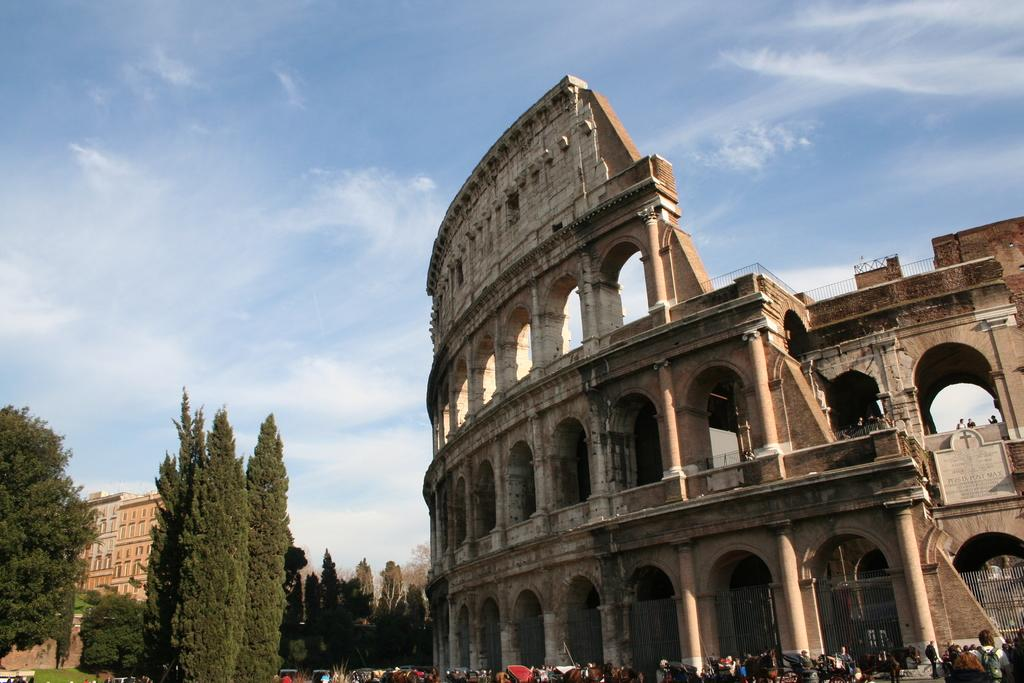What type of structures can be seen in the image? There are buildings in the image. What type of natural elements can be seen in the image? There are trees in the image. What type of living organisms can be seen in the image? There are people in the image. What is visible in the background of the image? The sky is visible in the image. What can be seen in the sky in the image? There are clouds in the image. What type of mine can be seen in the image? There is no mine present in the image. What type of wind can be seen in the image? There is no wind present in the image. 